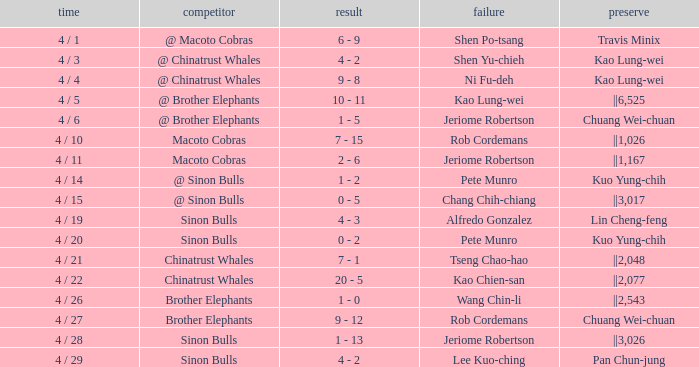Who earned the save in the game against the Sinon Bulls when Jeriome Robertson took the loss? ||3,026. 